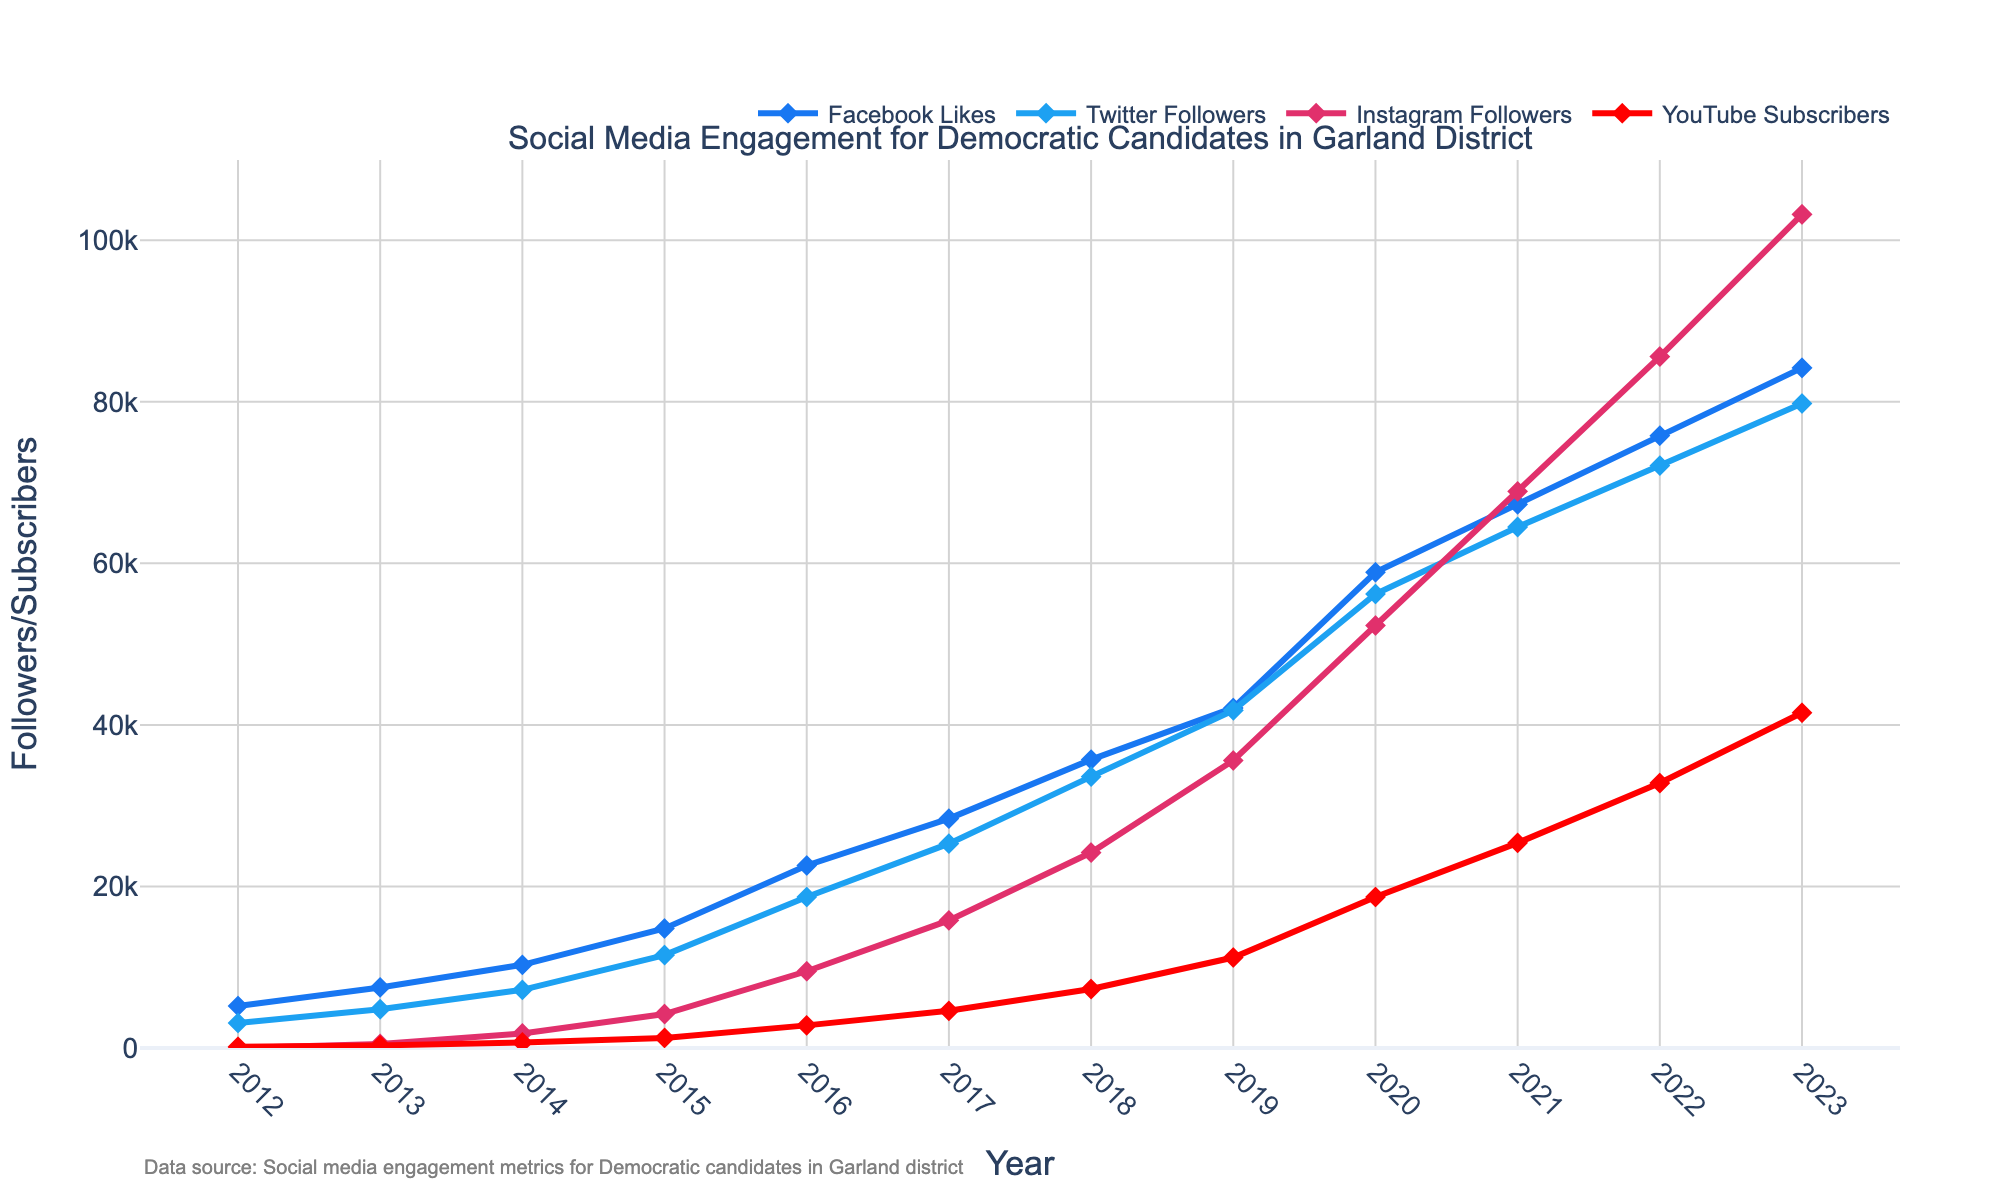What was the total number of followers and subscribers across all platforms in 2023? First, sum the number of followers/subscribers for each platform in 2023: Facebook (84,200) + Twitter (79,800) + Instagram (103,200) + YouTube (41,500). This gives 84,200 + 79,800 + 103,200 + 41,500 = 308,700.
Answer: 308,700 Which platform had the highest number of followers in 2018? Look at the data points for each platform in 2018: Facebook (35,700), Twitter (33,600), Instagram (24,200), YouTube (7,300). The highest value is Instagram with 24,200 followers.
Answer: Instagram By how much did the number of Facebook likes increase from 2016 to 2023? Subtract the number of Facebook likes in 2016 (22,600) from the number in 2023 (84,200): 84,200 - 22,600 = 61,600.
Answer: 61,600 Between 2020 and 2023, which platform saw the largest percentage increase in followers/subscribers? Calculate the percentage increase for each platform: 
Facebook: ((84,200 - 58,900) / 58,900) * 100 ≈ 42.92% 
Twitter: ((79,800 - 56,200) / 56,200) * 100 ≈ 41.96% 
Instagram: ((103,200 - 52,300) / 52,300) * 100 ≈ 97.31% 
YouTube: ((41,500 - 18,700) / 18,700) * 100 ≈ 121.39%
The largest increase is for YouTube with approximately 121.39%.
Answer: YouTube What is the average number of Instagram followers from 2017 to 2020? Sum the number of Instagram followers from 2017 to 2020: 15,800 + 24,200 + 35,600 + 52,300 = 127,900. Divide this by the number of years (4): 127,900 / 4 ≈ 31,975.
Answer: 31,975 Which year saw the largest increase in YouTube subscribers compared to the previous year? Calculate the yearly increases for YouTube:
2013-2012: 320 - 150 = 170 
2014-2013: 680 - 320 = 360 
2015-2014: 1,250 - 680 = 570 
2016-2015: 2,800 - 1,250 = 1,550 
2017-2016: 4,600 - 2,800 = 1,800 
2018-2017: 7,300 - 4,600 = 2,700 
2019-2018: 11,200 - 7,300 = 3,900 
2020-2019: 18,700 - 11,200 = 7,500 
2021-2020: 25,400 - 18,700 = 6,700 
2022-2021: 32,800 - 25,400 = 7,400 
2023-2022: 41,500 - 32,800 = 8,700
The largest increase is between 2022 and 2023 with 8,700.
Answer: 2023 How does the trend of Instagram followers compare to Twitter followers from 2015 to 2019 visually? Visually assess the trends from 2015 to 2019. Instagram followers show a steep increase starting at 4,200 in 2015 and reaching 35,600 in 2019. Twitter followers show a steadier, less steep increase starting at 11,500 in 2015 and reaching 41,800 in 2019. Instagram's growth is much more rapid compared to Twitter during this period.
Answer: Instagram's trend is steeper What is the median number of YouTube subscribers across all years? Arrange the YouTube subscribers in ascending order: 150, 320, 680, 1,250, 2,800, 4,600, 7,300, 11,200, 18,700, 25,400, 32,800, 41,500. The median value is the average of the middle two numbers in an even dataset: (4,600 + 7,300) / 2 = 5,950.
Answer: 5,950 